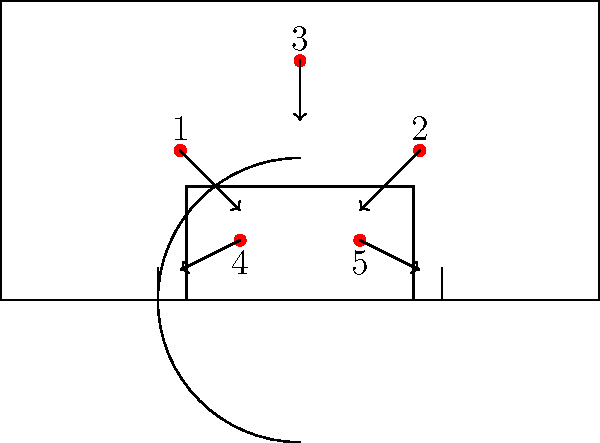In the given offensive play setup, which player is most likely to set a screen for the ball handler (player 3) as they drive towards the basket? To determine which player is most likely to set a screen for the ball handler (player 3), we need to analyze the positioning and movement patterns of all players:

1. Player 3 is at the top of the key and is moving towards the basket.
2. Players 1 and 2 are on the wings and are moving towards the corners, likely to spread the defense and create space.
3. Players 4 and 5 are in the low post areas and are moving towards the baseline.

Given these movements:

1. Players 1 and 2 are moving away from the ball handler, making it unlikely for them to set a screen.
2. Players 4 and 5 are in the best position to set a screen as the ball handler drives towards the basket.
3. Between players 4 and 5, player 4 is on the same side as the likely driving lane of player 3 (assuming a right-handed player).

Therefore, player 4 is in the most advantageous position to set a screen for the ball handler as they drive towards the basket. This screen would likely be a "step-up" screen, where player 4 moves up from the low post to set a screen on the defender guarding player 3.
Answer: Player 4 